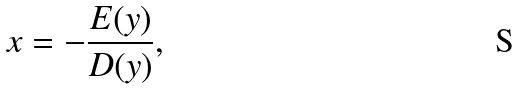Convert formula to latex. <formula><loc_0><loc_0><loc_500><loc_500>x = - \frac { E ( y ) } { D ( y ) } ,</formula> 